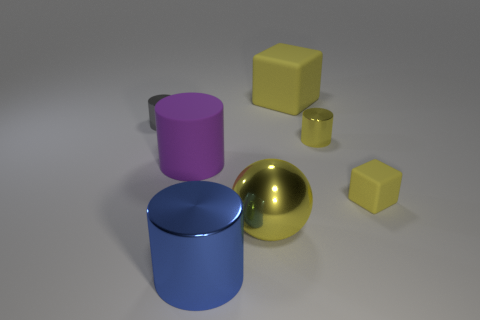Add 1 small brown shiny cylinders. How many objects exist? 8 Subtract all spheres. How many objects are left? 6 Subtract 1 purple cylinders. How many objects are left? 6 Subtract all matte cylinders. Subtract all gray metallic cylinders. How many objects are left? 5 Add 5 big purple rubber cylinders. How many big purple rubber cylinders are left? 6 Add 4 big brown spheres. How many big brown spheres exist? 4 